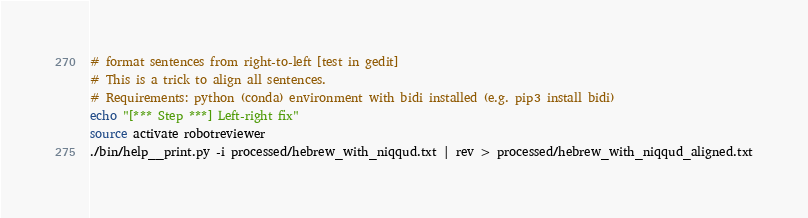<code> <loc_0><loc_0><loc_500><loc_500><_Bash_># format sentences from right-to-left [test in gedit]
# This is a trick to align all sentences.
# Requirements: python (conda) environment with bidi installed (e.g. pip3 install bidi)
echo "[*** Step ***] Left-right fix"
source activate robotreviewer
./bin/help__print.py -i processed/hebrew_with_niqqud.txt | rev > processed/hebrew_with_niqqud_aligned.txt

</code> 